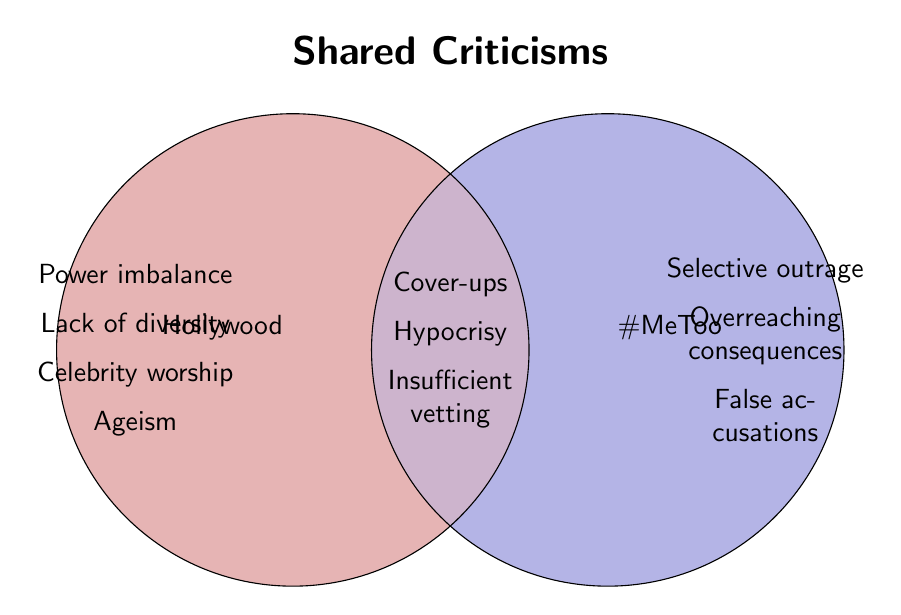What are the issues listed for Hollywood but not for the #MeToo movement? There are four issues specifically mentioned under Hollywood: Power imbalance, Lack of diversity, Celebrity worship, and Ageism, which are not listed under the #MeToo movement.
Answer: Power imbalance, Lack of diversity, Celebrity worship, Ageism What are the criticisms common to both Hollywood and the #MeToo movement? The criticisms in the overlapping section of the Venn diagram are Cover-ups, Hypocrisy, and Insufficient vetting.
Answer: Cover-ups, Hypocrisy, Insufficient vetting Which category contains the criticism "False accusations"? The "False accusations" criticism appears in the section specifically attributed to the #MeToo movement.
Answer: #MeToo movement How many unique criticisms are there in total in the Venn diagram? Hollywood has 4 unique criticisms, the #MeToo movement has 3 unique criticisms, and there are 3 shared criticisms. Summing them up, it gives a total of 10 unique criticisms.
Answer: 10 Is "Selective outrage" a shared criticism between Hollywood and the #MeToo movement? "Selective outrage" is listed under the #MeToo movement, not in the shared section, so it is not a shared criticism.
Answer: No Does the Hollywood section mention "Insufficient vetting"? "Insufficient vetting" is in the shared section, not the Hollywood section.
Answer: No Which has more unique criticisms, Hollywood, or the #MeToo movement? Hollywood has 4 unique criticisms (Power imbalance, Lack of diversity, Celebrity worship, Ageism) while the #MeToo movement has 3 unique criticisms (Selective outrage, Overreaching consequences, False accusations). Therefore, Hollywood has more unique criticisms.
Answer: Hollywood Are there more criticisms listed uniquely under Hollywood or in the shared section? Hollywood has 4 unique criticisms, while the shared section includes 3 criticisms. Hollywood has more unique criticisms.
Answer: Hollywood What color is used to demarcate issues related to Hollywood? The circle related to Hollywood is filled with a light red or salmon color.
Answer: Light red/salmon 